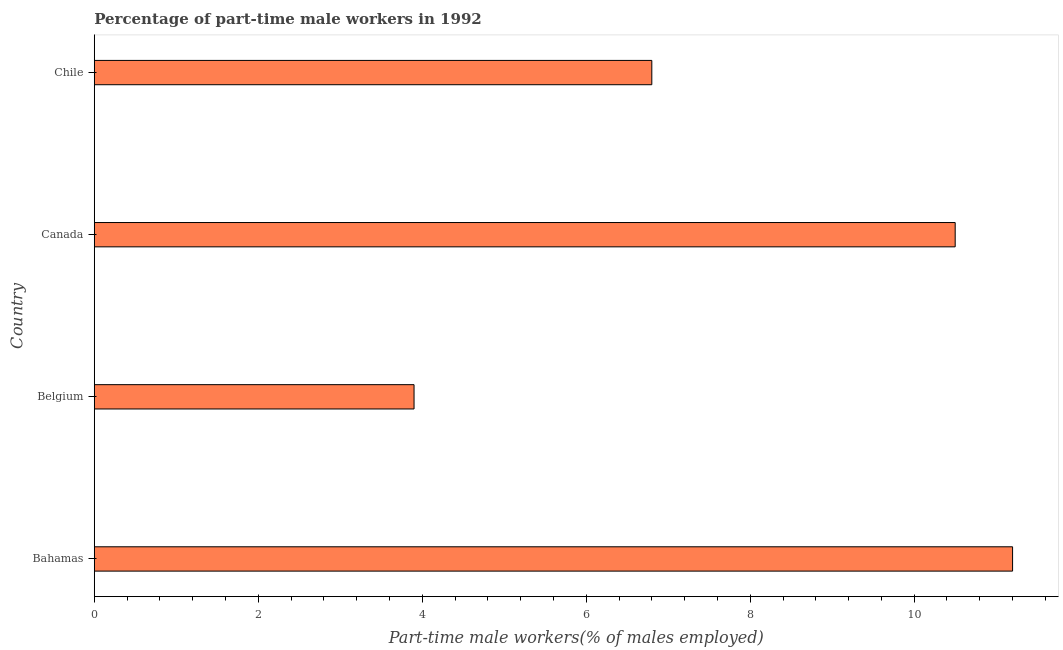Does the graph contain any zero values?
Provide a short and direct response. No. What is the title of the graph?
Keep it short and to the point. Percentage of part-time male workers in 1992. What is the label or title of the X-axis?
Offer a terse response. Part-time male workers(% of males employed). What is the label or title of the Y-axis?
Provide a short and direct response. Country. Across all countries, what is the maximum percentage of part-time male workers?
Ensure brevity in your answer.  11.2. Across all countries, what is the minimum percentage of part-time male workers?
Keep it short and to the point. 3.9. In which country was the percentage of part-time male workers maximum?
Your response must be concise. Bahamas. What is the sum of the percentage of part-time male workers?
Provide a succinct answer. 32.4. What is the average percentage of part-time male workers per country?
Keep it short and to the point. 8.1. What is the median percentage of part-time male workers?
Your answer should be compact. 8.65. In how many countries, is the percentage of part-time male workers greater than 6 %?
Offer a very short reply. 3. What is the ratio of the percentage of part-time male workers in Canada to that in Chile?
Offer a very short reply. 1.54. In how many countries, is the percentage of part-time male workers greater than the average percentage of part-time male workers taken over all countries?
Give a very brief answer. 2. How many bars are there?
Provide a succinct answer. 4. Are all the bars in the graph horizontal?
Provide a short and direct response. Yes. What is the difference between two consecutive major ticks on the X-axis?
Provide a succinct answer. 2. What is the Part-time male workers(% of males employed) of Bahamas?
Your answer should be very brief. 11.2. What is the Part-time male workers(% of males employed) of Belgium?
Keep it short and to the point. 3.9. What is the Part-time male workers(% of males employed) in Canada?
Give a very brief answer. 10.5. What is the Part-time male workers(% of males employed) of Chile?
Provide a short and direct response. 6.8. What is the difference between the Part-time male workers(% of males employed) in Bahamas and Belgium?
Your answer should be very brief. 7.3. What is the difference between the Part-time male workers(% of males employed) in Bahamas and Canada?
Make the answer very short. 0.7. What is the difference between the Part-time male workers(% of males employed) in Bahamas and Chile?
Ensure brevity in your answer.  4.4. What is the difference between the Part-time male workers(% of males employed) in Belgium and Canada?
Offer a terse response. -6.6. What is the difference between the Part-time male workers(% of males employed) in Belgium and Chile?
Give a very brief answer. -2.9. What is the difference between the Part-time male workers(% of males employed) in Canada and Chile?
Keep it short and to the point. 3.7. What is the ratio of the Part-time male workers(% of males employed) in Bahamas to that in Belgium?
Give a very brief answer. 2.87. What is the ratio of the Part-time male workers(% of males employed) in Bahamas to that in Canada?
Offer a very short reply. 1.07. What is the ratio of the Part-time male workers(% of males employed) in Bahamas to that in Chile?
Give a very brief answer. 1.65. What is the ratio of the Part-time male workers(% of males employed) in Belgium to that in Canada?
Your answer should be compact. 0.37. What is the ratio of the Part-time male workers(% of males employed) in Belgium to that in Chile?
Keep it short and to the point. 0.57. What is the ratio of the Part-time male workers(% of males employed) in Canada to that in Chile?
Provide a succinct answer. 1.54. 